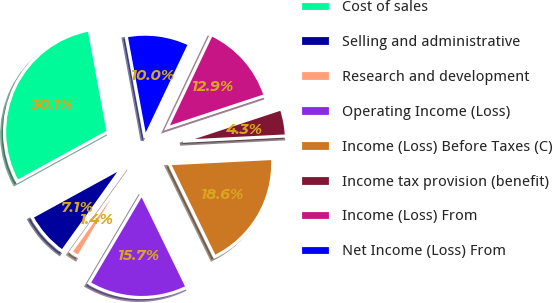Convert chart. <chart><loc_0><loc_0><loc_500><loc_500><pie_chart><fcel>Cost of sales<fcel>Selling and administrative<fcel>Research and development<fcel>Operating Income (Loss)<fcel>Income (Loss) Before Taxes (C)<fcel>Income tax provision (benefit)<fcel>Income (Loss) From<fcel>Net Income (Loss) From<nl><fcel>30.06%<fcel>7.13%<fcel>1.39%<fcel>15.72%<fcel>18.59%<fcel>4.26%<fcel>12.86%<fcel>9.99%<nl></chart> 